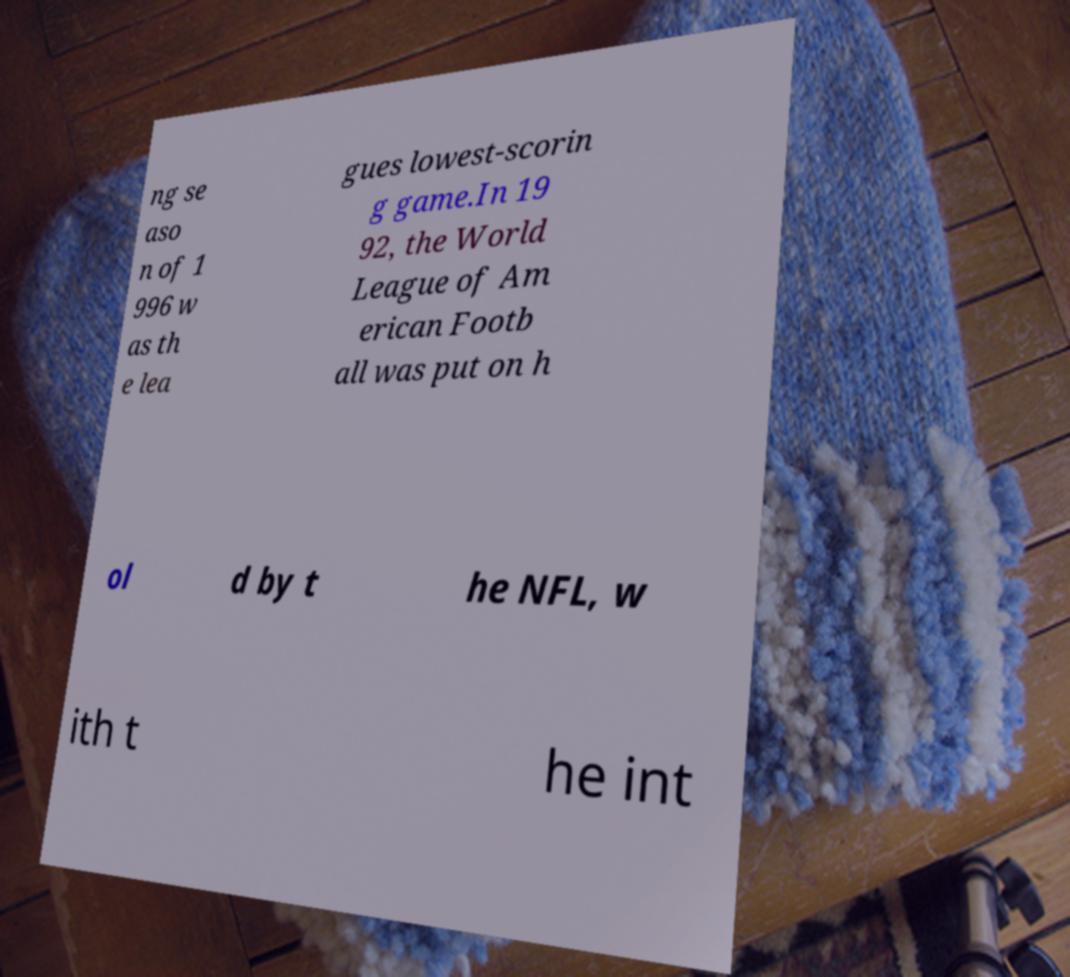Could you extract and type out the text from this image? ng se aso n of 1 996 w as th e lea gues lowest-scorin g game.In 19 92, the World League of Am erican Footb all was put on h ol d by t he NFL, w ith t he int 